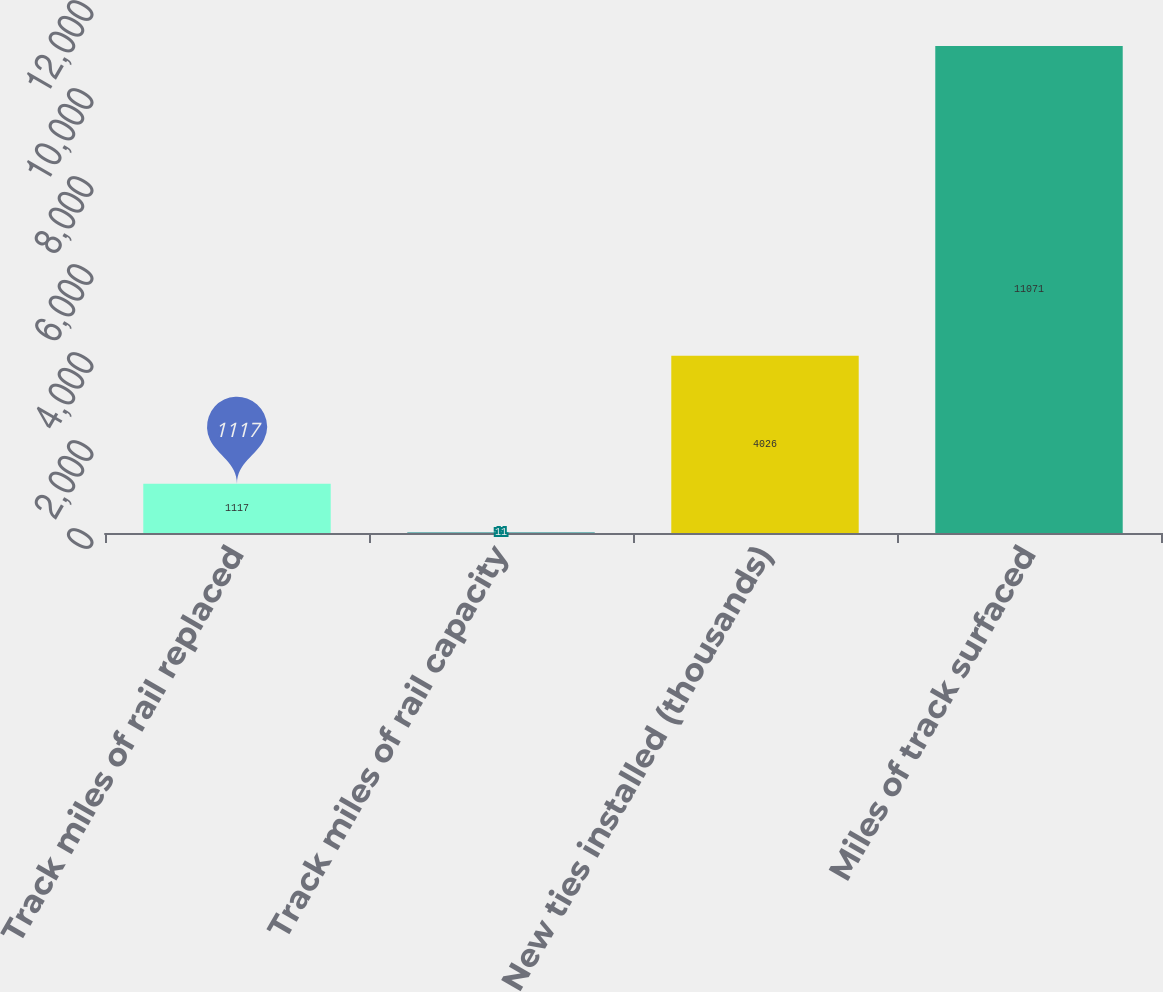<chart> <loc_0><loc_0><loc_500><loc_500><bar_chart><fcel>Track miles of rail replaced<fcel>Track miles of rail capacity<fcel>New ties installed (thousands)<fcel>Miles of track surfaced<nl><fcel>1117<fcel>11<fcel>4026<fcel>11071<nl></chart> 